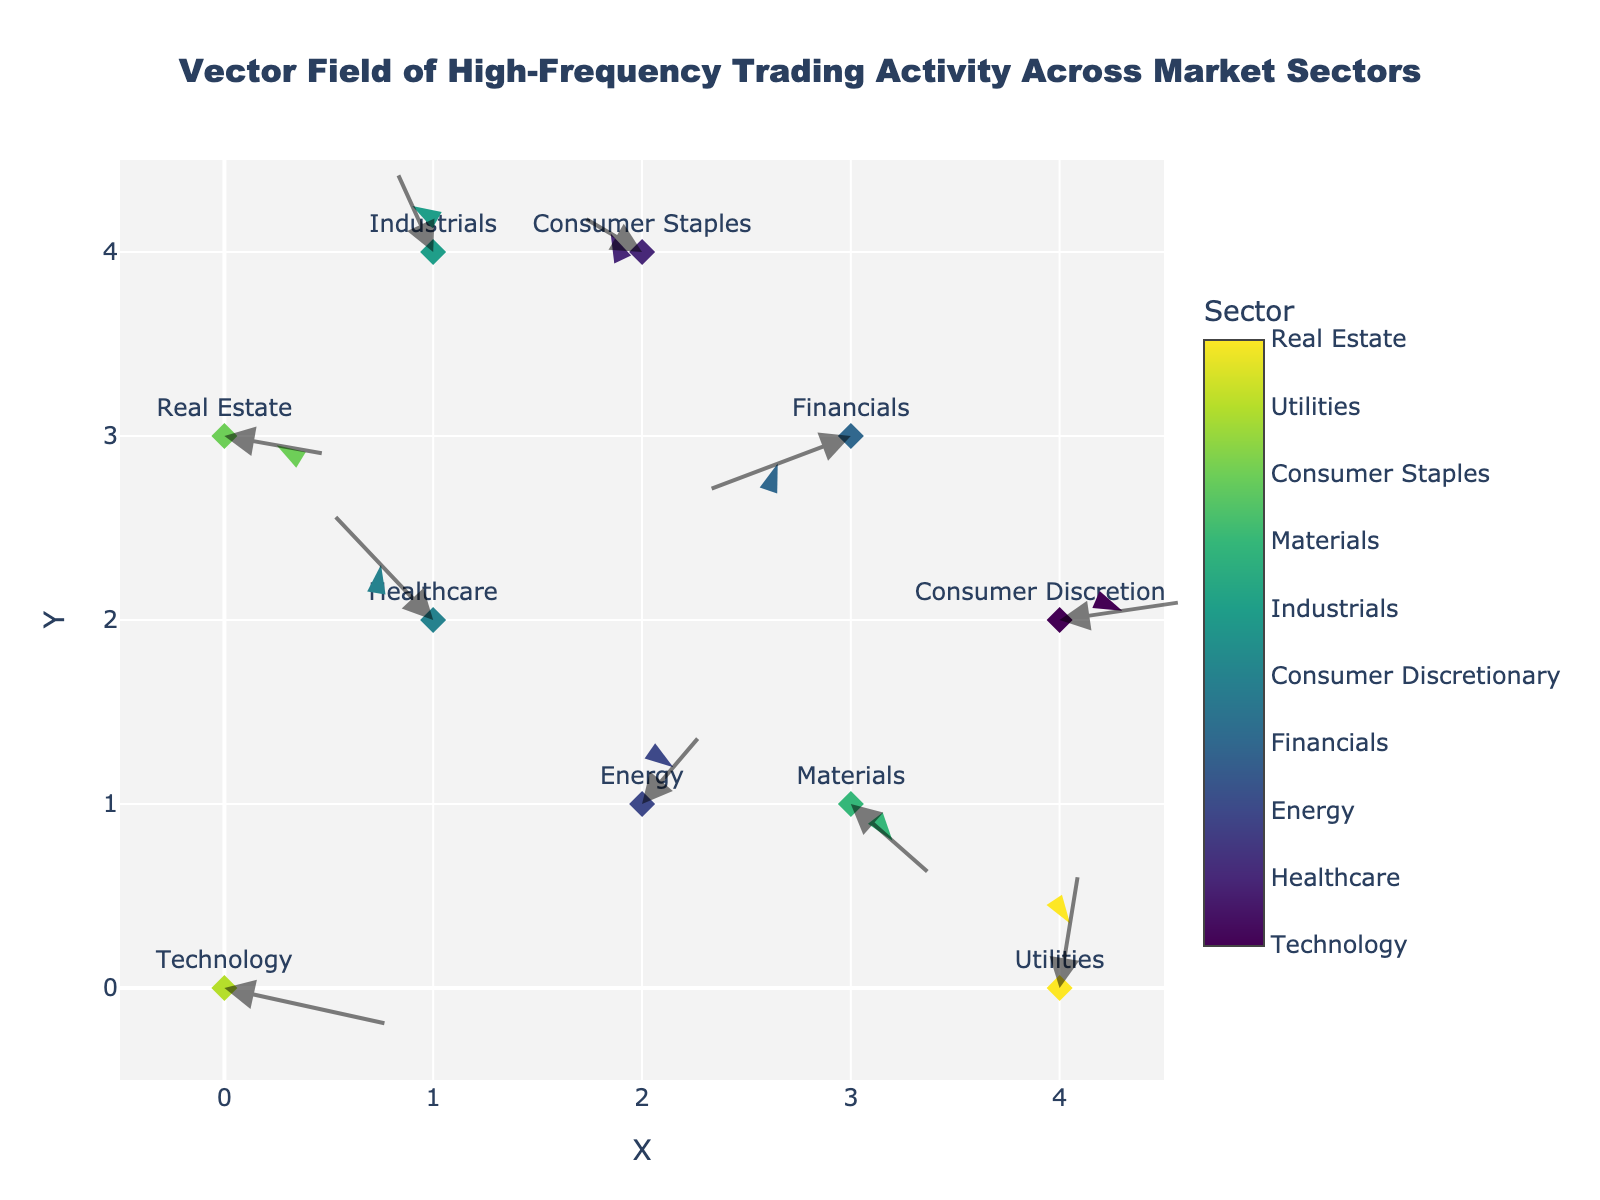What is the title of the figure? The title is a descriptive element typically located at the top of the figure. In this case, it is clearly displayed.
Answer: Vector Field of High-Frequency Trading Activity Across Market Sectors What are the x-axis and y-axis range values? The x-axis and y-axis ranges are listed on the figure's axis. The x-axis ranges from -0.5 to 4.5, and the y-axis ranges from -0.5 to 4.5.
Answer: -0.5 to 4.5 How many sectors are represented in the figure? Each unique color and label represents a different market sector. Counting these, we can determine the number of sectors displayed in the figure. There are ten unique sectors mentioned.
Answer: 10 Which sectors have vectors originating from the point (2,1)? By examining the origin points of the vectors, we can identify which sector label corresponds to the coordinates (2,1).
Answer: Energy Which sector exhibits the longest vector and what is its magnitude? The length of a vector can be computed using the Euclidean norm (sqrt(u^2 + v^2)). By visually inspecting the plot or calculating the lengths, we can find the longest vector. The Technology sector has vector coordinates (0.8, -0.2) with a magnitude of sqrt(0.8^2 + (-0.2)^2) = sqrt(0.68) = 0.824.
Answer: Technology, 0.824 Explain the direction of the vector for Real Estate. The direction of a vector is indicated by the arrow from its origin point. The Real Estate vector originates at point (0,3) and points in the (0.5,-0.1) direction, moving rightward and slightly downward.
Answer: Right and slightly downward Which sectors have vectors pointing primarily in the positive x-direction? Vectors pointing primarily in the positive x-direction have positive u components. Identify sectors with a positive u component to answer this.
Answer: Technology, Energy, Consumer Discretionary, Materials, Utilities Compare the vectors of Financials and Healthcare sectors. Which one has a larger magnitude? The magnitudes of the Financials and Healthcare vectors are calculated using sqrt(u^2 + v^2). Financials are (-0.7, -0.3) with a magnitude of sqrt(0.58) and Healthcare is (-0.5, 0.6) with a magnitude of sqrt(0.61). The Healthcare sector has a larger magnitude.
Answer: Healthcare For the vectors originating from x = 4, how do their directions differ? Examine the directions of vectors originating from x = 4. The sectors are Consumer Discretionary (0.6, 0.1) pointing right and slightly upward, and Utilities (0.1, 0.7) pointing right and more upward. Compare these directions.
Answer: Consumer Discretionary: right and slightly upward, Utilities: right and more upward 